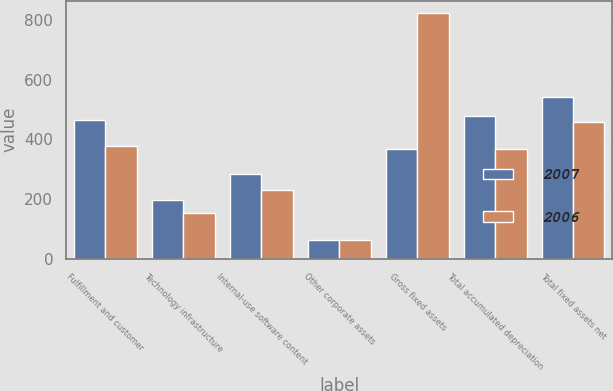<chart> <loc_0><loc_0><loc_500><loc_500><stacked_bar_chart><ecel><fcel>Fulfillment and customer<fcel>Technology infrastructure<fcel>Internal-use software content<fcel>Other corporate assets<fcel>Gross fixed assets<fcel>Total accumulated depreciation<fcel>Total fixed assets net<nl><fcel>2007<fcel>464<fcel>196<fcel>285<fcel>63<fcel>367<fcel>480<fcel>543<nl><fcel>2006<fcel>379<fcel>153<fcel>230<fcel>62<fcel>824<fcel>367<fcel>457<nl></chart> 